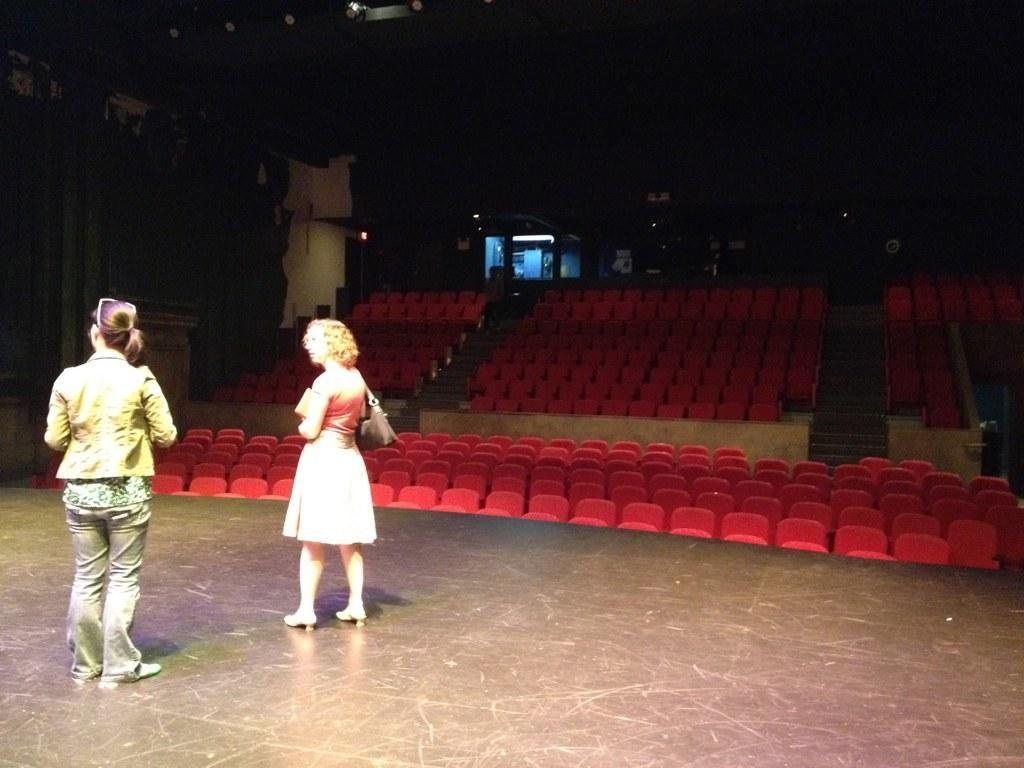Can you describe this image briefly? In this picture, we see two women are standing on the stage. Behind them, we see many red color chairs. In the background, we see a pillar and a window. It is dark in the background. This picture is clicked in the auditorium. 